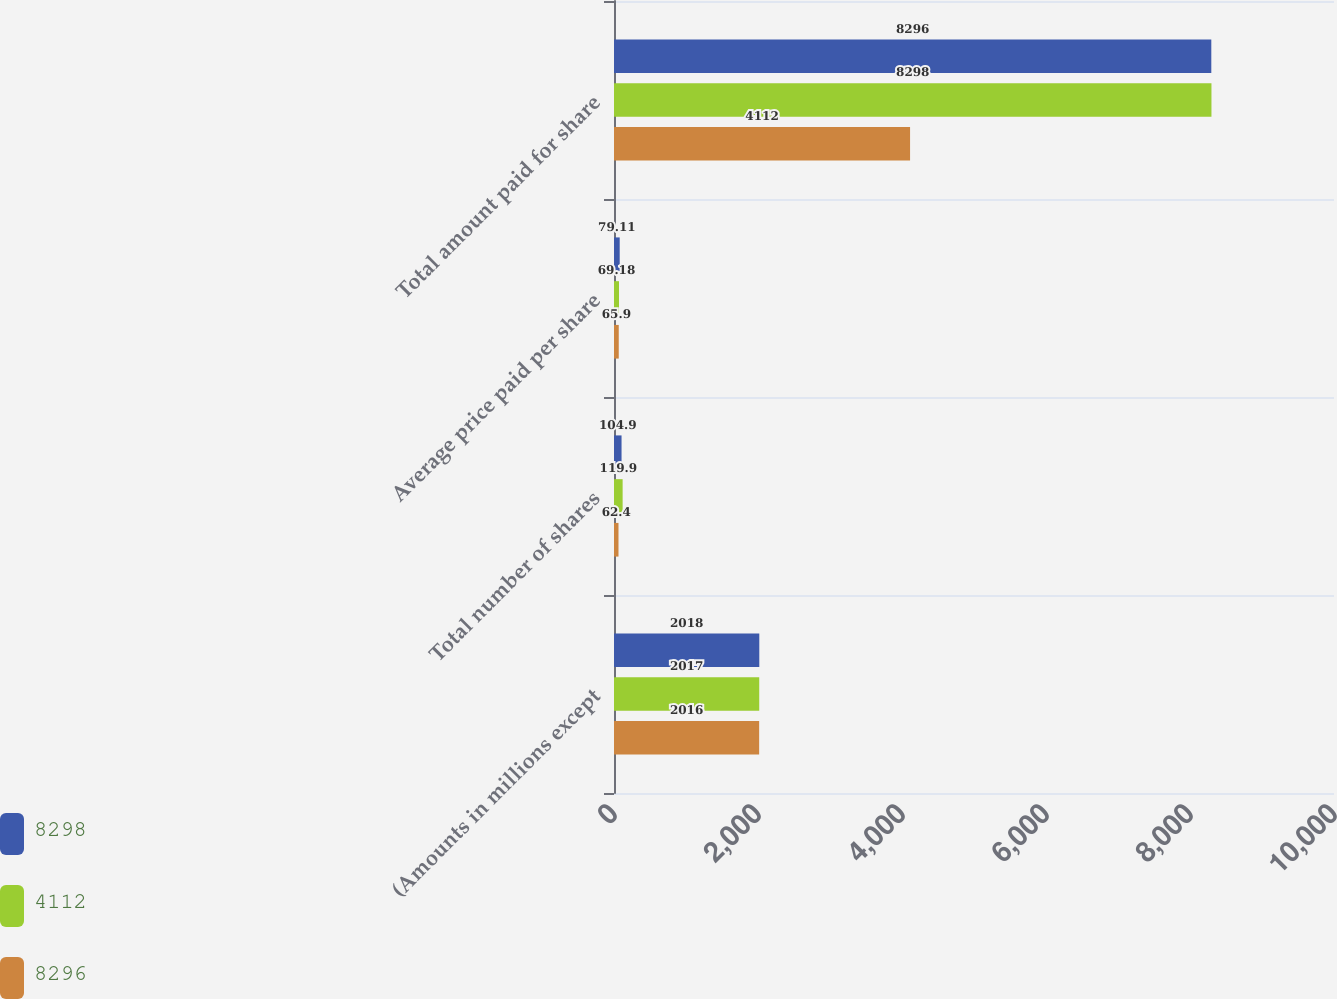<chart> <loc_0><loc_0><loc_500><loc_500><stacked_bar_chart><ecel><fcel>(Amounts in millions except<fcel>Total number of shares<fcel>Average price paid per share<fcel>Total amount paid for share<nl><fcel>8298<fcel>2018<fcel>104.9<fcel>79.11<fcel>8296<nl><fcel>4112<fcel>2017<fcel>119.9<fcel>69.18<fcel>8298<nl><fcel>8296<fcel>2016<fcel>62.4<fcel>65.9<fcel>4112<nl></chart> 